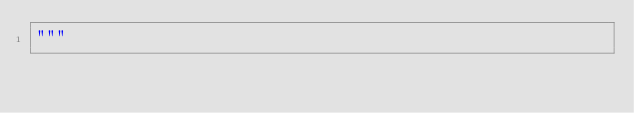Convert code to text. <code><loc_0><loc_0><loc_500><loc_500><_Python_>"""


</code> 